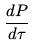<formula> <loc_0><loc_0><loc_500><loc_500>\frac { d P } { d \tau }</formula> 